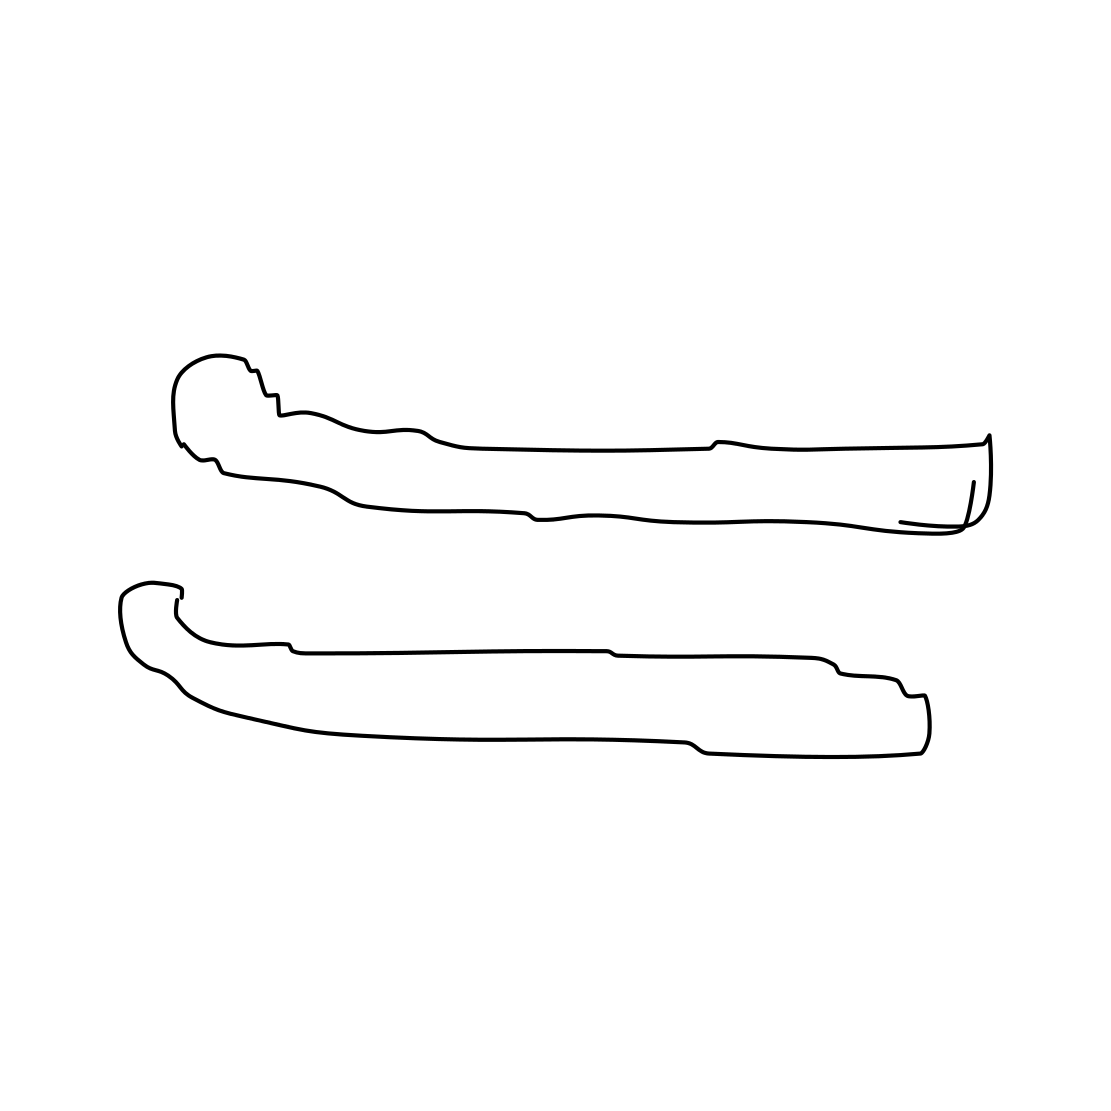Do these objects resemble something from nature? The illustration has a certain organic quality to it, perhaps resembling bones or driftwood due to their elongated shapes and curves. They mimic the natural lines we might find in branches or other objects worn by time and the elements. 